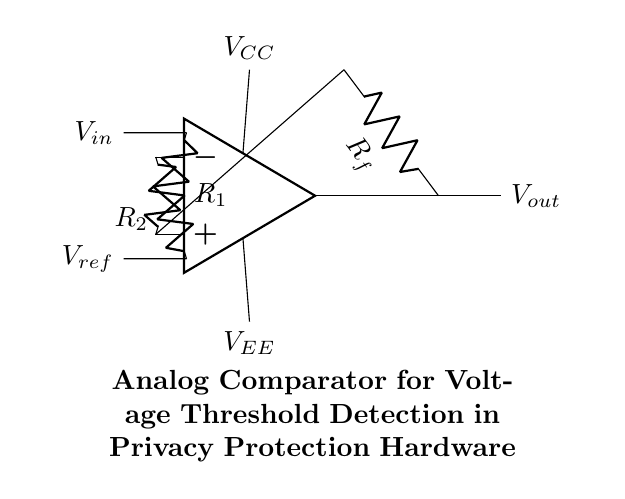What type of circuit is depicted? The circuit shown is an analog comparator, which compares two input voltages and produces an output based on their comparison.
Answer: analog comparator What are the two types of input voltages? There are two input voltages indicated: the first is the non-inverting input labeled as V_in, and the second is the inverting input labeled as V_ref.
Answer: V_in and V_ref What is the purpose of R_f in this circuit? R_f is the feedback resistor, which helps set the gain of the comparator and influences the output voltage based on the input differences.
Answer: feedback resistor If V_in is greater than V_ref, what happens to V_out? If V_in exceeds V_ref, the output voltage, V_out, will swing to a high state, typically close to V_CC, indicating a positive comparison.
Answer: V_out goes high What components determine the reference voltage? The reference voltage is determined by the resistor R_2, which connects to the inverting input of the op-amp.
Answer: R_2 How does the power supply voltage affect the operation of the comparator? The power supply voltages V_CC and V_EE set the limits for the output voltage swing; V_out cannot exceed these supply levels during operation.
Answer: V_CC and V_EE 